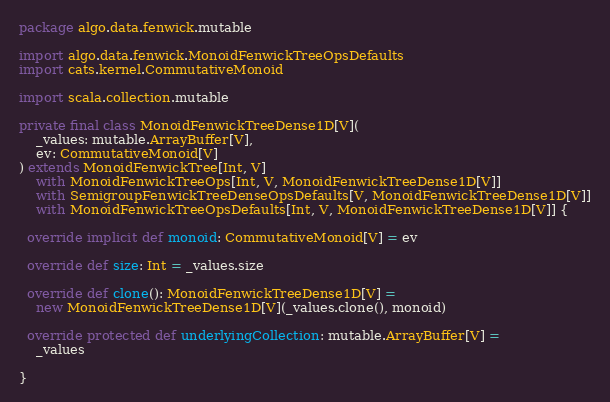<code> <loc_0><loc_0><loc_500><loc_500><_Scala_>package algo.data.fenwick.mutable

import algo.data.fenwick.MonoidFenwickTreeOpsDefaults
import cats.kernel.CommutativeMonoid

import scala.collection.mutable

private final class MonoidFenwickTreeDense1D[V](
    _values: mutable.ArrayBuffer[V],
    ev: CommutativeMonoid[V]
) extends MonoidFenwickTree[Int, V]
    with MonoidFenwickTreeOps[Int, V, MonoidFenwickTreeDense1D[V]]
    with SemigroupFenwickTreeDenseOpsDefaults[V, MonoidFenwickTreeDense1D[V]]
    with MonoidFenwickTreeOpsDefaults[Int, V, MonoidFenwickTreeDense1D[V]] {

  override implicit def monoid: CommutativeMonoid[V] = ev

  override def size: Int = _values.size

  override def clone(): MonoidFenwickTreeDense1D[V] =
    new MonoidFenwickTreeDense1D[V](_values.clone(), monoid)

  override protected def underlyingCollection: mutable.ArrayBuffer[V] =
    _values

}
</code> 